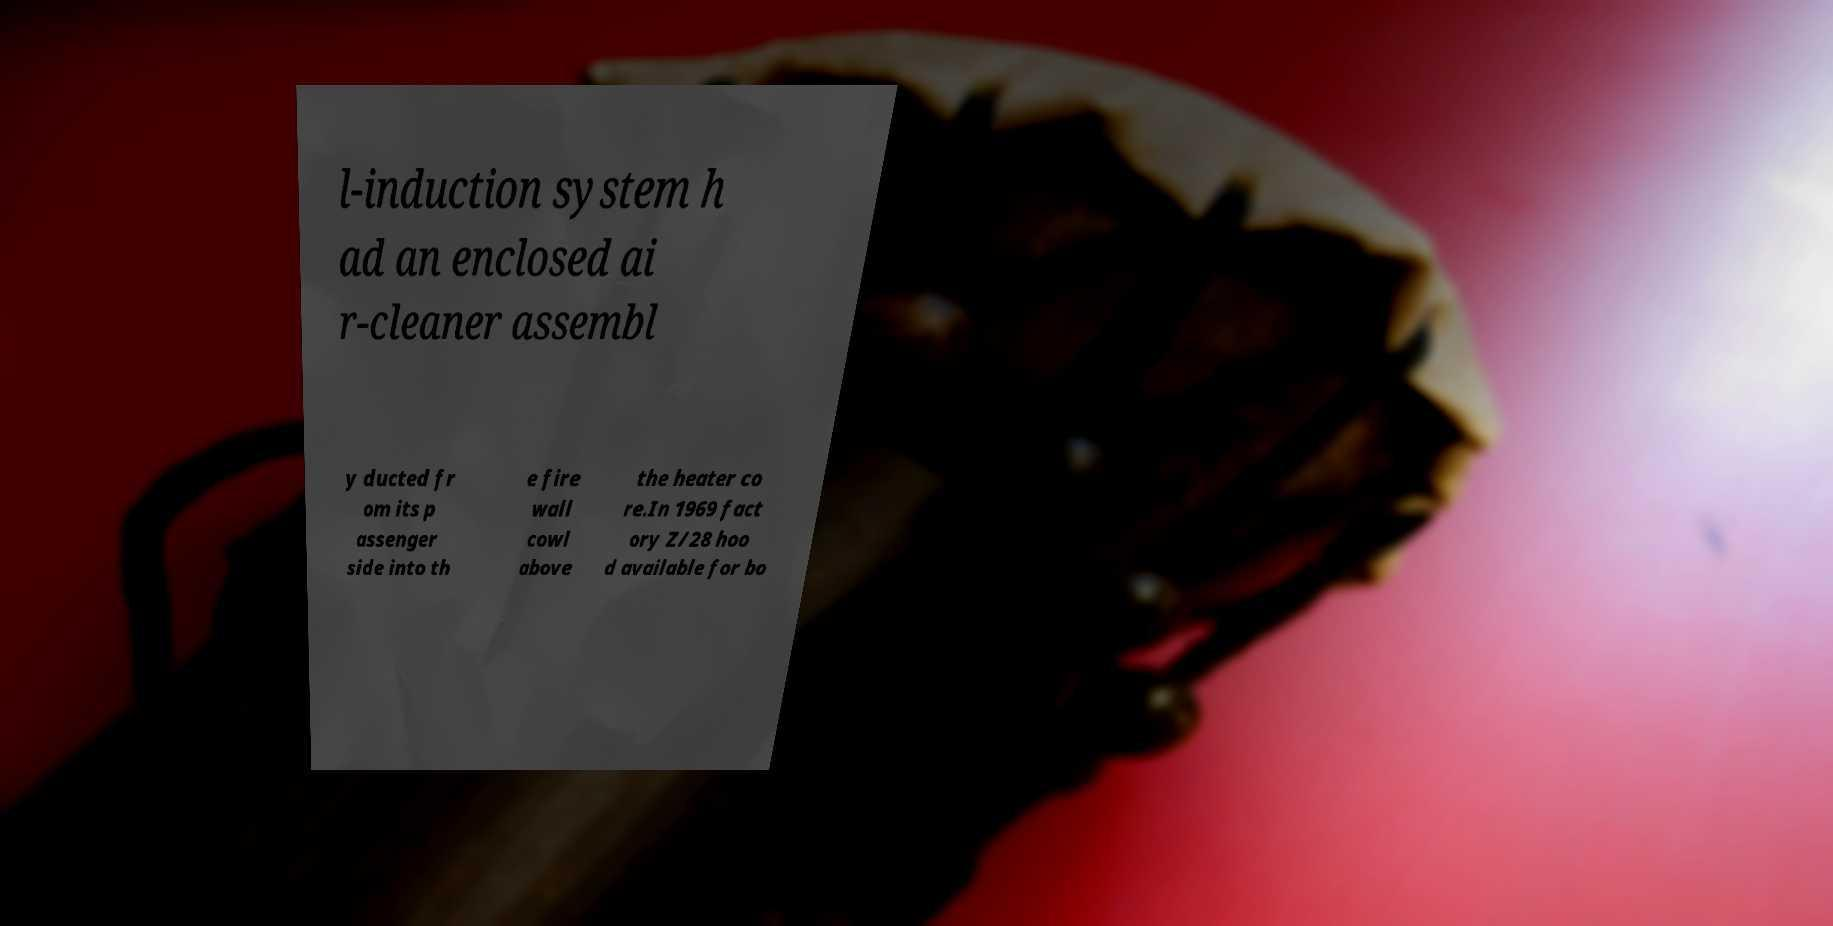Can you accurately transcribe the text from the provided image for me? l-induction system h ad an enclosed ai r-cleaner assembl y ducted fr om its p assenger side into th e fire wall cowl above the heater co re.In 1969 fact ory Z/28 hoo d available for bo 